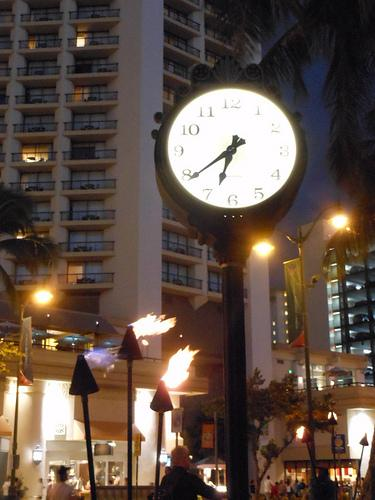Using a storytelling style, describe what is happening in the image. At night in the city, as the clock's face glows on a towering pole, vibrant flames erupt from tall torches. People casually walk by, their shirts white and black against the dimly-lit scene. Give a concise description of the image focusing on the most prominent feature. A large illuminated clock on a pole at night with torches and people around and buildings in the backdrop. State the setting and the most striking aspect of the image. A nighttime cityscape with an eye-catching illuminated clock on a pole, and torches, people, and buildings in the background. Write a brief headline-style description of the image. Illuminated Clock Tower Surrounded by Flames, Buildings, and People at Night Present a brief scene description of the image. A night scene with a large clock on a pole, torches ablaze nearby, people passing by, and buildings with balconies and illuminated windows in the background. Mention the key elements seen in the image. A large clock, torches with flames, people wearing black and white shirts, buildings in the background, a blue sign, a tree, and a parking garage. Describe the location and atmosphere of the image. An urban setting at nighttime with a mix of lit-up elements like a clock, torches, streetlights, and people walking around, creating a lively ambiance. Focus on the people in the image and describe the scene around them. People wearing black and white shirts stroll through a lively night scene with flaming torches, an illuminated clock, streetlights, and large buildings in the background. Provide a description of the image focusing on the flames. Flames vividly shine in the darkness as they emerge from torches, surrounded by a bustling night scene with an illuminated clock, people, and large buildings. Describe the lighting and atmosphere of the image. The image features a dimly lit nighttime scene with an illuminated clock, flaming torches, glowing streetlights, and illuminated windows, creating a warm atmosphere. 